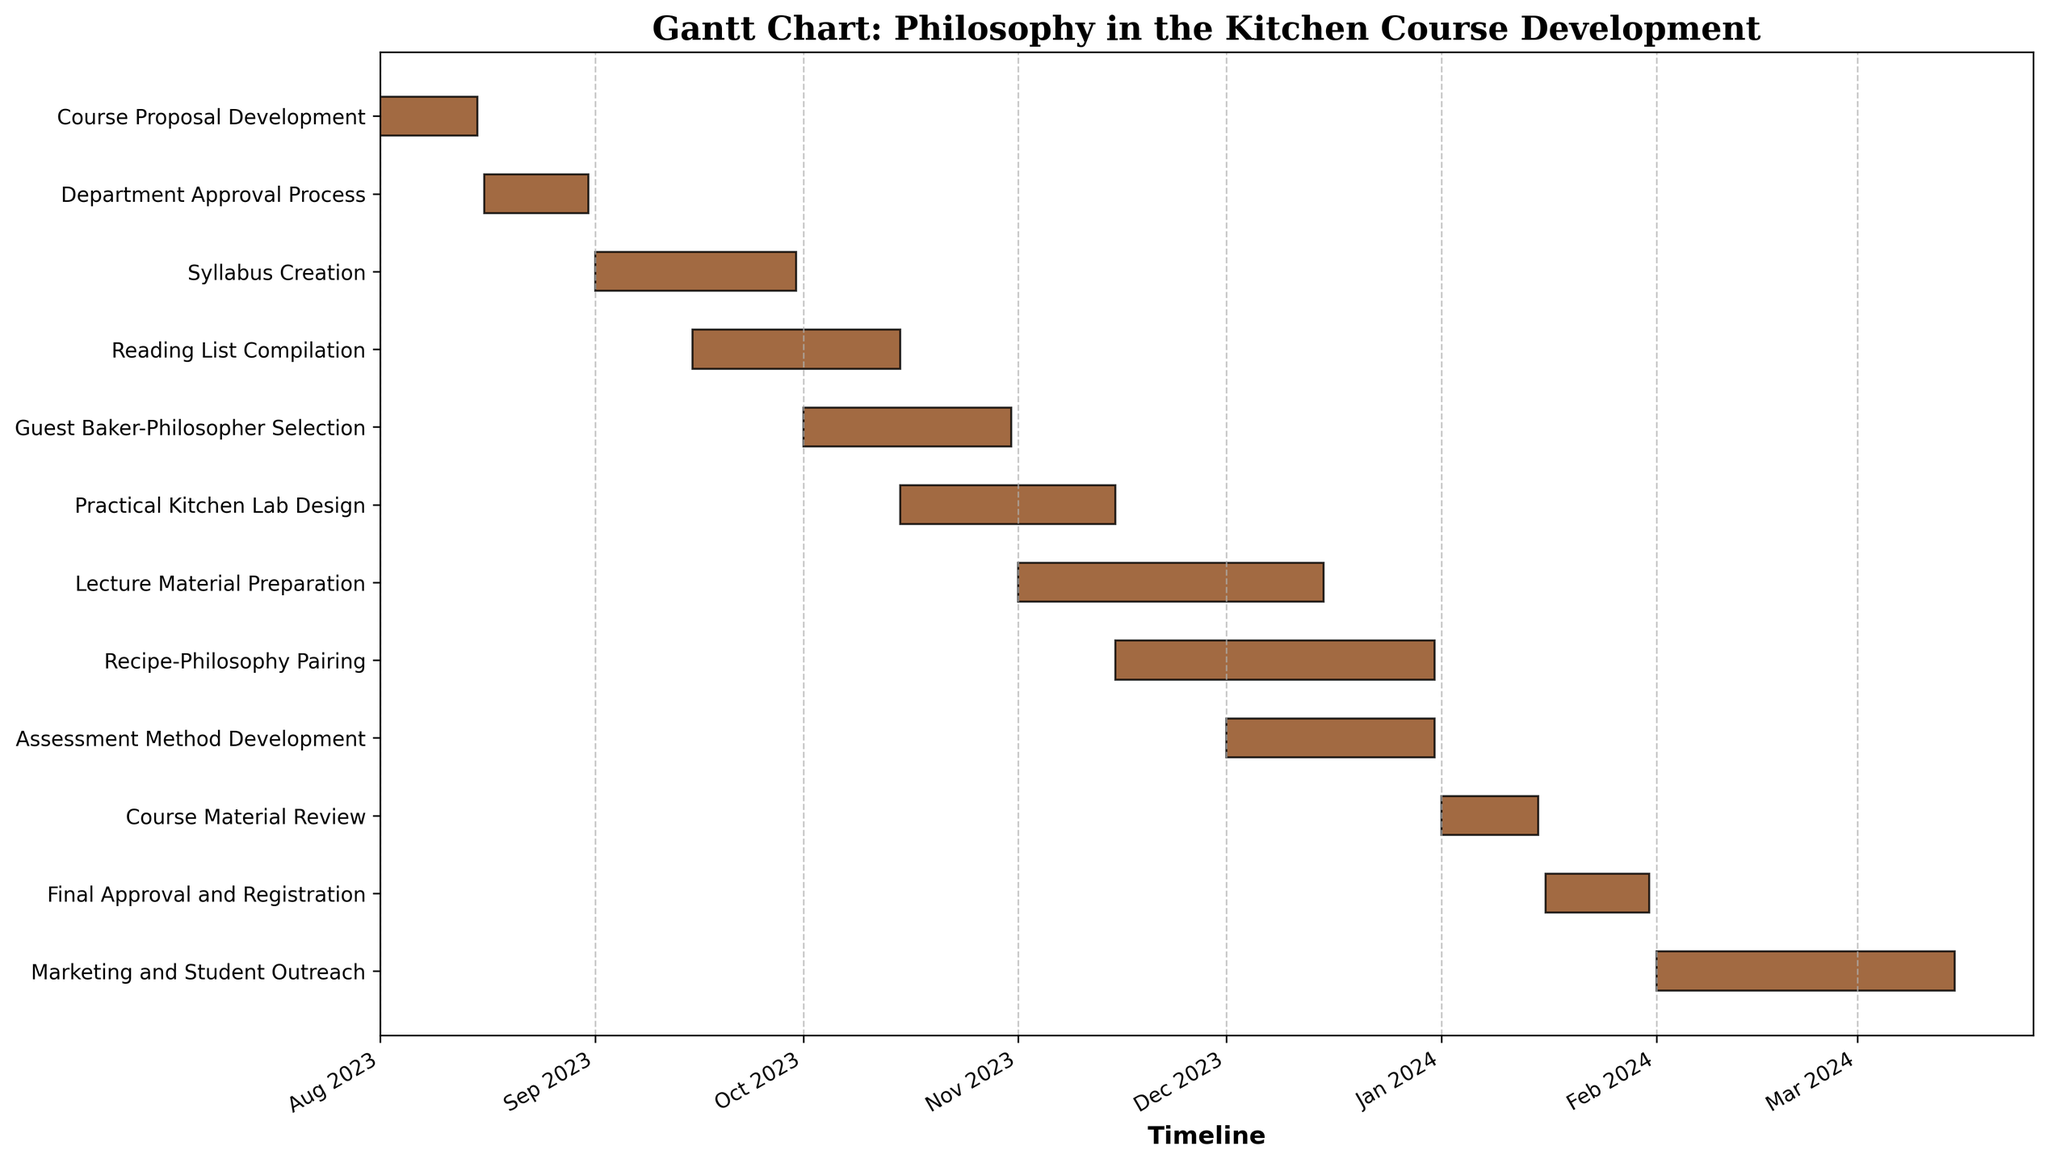What is the title of the Gantt chart? The title is usually located at the top of the Gantt chart and is prominently displayed. It is used to inform the viewer about the main subject of the chart. In this case, it reads "Gantt Chart: Philosophy in the Kitchen Course Development".
Answer: Gantt Chart: Philosophy in the Kitchen Course Development How many tasks are scheduled to start in August 2023? By looking at the start dates of the tasks listed on the left side of the chart, identify which tasks begin in August 2023. "Course Proposal Development" and "Department Approval Process" both start in August 2023.
Answer: 2 What is the duration of "Lecture Material Preparation"? To find the duration, refer to the bar representing "Lecture Material Preparation" on the Gantt chart, which extends from the start date in November 2023 to the end date in December 2023. The duration specified in the data is 45 days.
Answer: 45 Which task has the longest duration, and how long is it? By comparing the lengths of all the bars representing each task, you can see that "Recipe-Philosophy Pairing" stretches the longest. According to the data provided, this task lasts for 47 days.
Answer: Recipe-Philosophy Pairing, 47 days Which tasks overlap with the "Reading List Compilation"? Identify the tasks that have any portion of their bar overlapping with the duration of the “Reading List Compilation” from mid-September to mid-October 2023. The tasks overlapping are "Syllabus Creation" and "Guest Baker-Philosopher Selection".
Answer: Syllabus Creation, Guest Baker-Philosopher Selection When does "Course Material Review" start and end? Refer to the "Course Material Review" bar on the Gantt chart to find its start and end dates. According to the chart, it starts in January 2024 and ends in mid-January 2024.
Answer: January 1, 2024, to January 15, 2024 How many tasks are scheduled to be completed by the end of 2023? Identify tasks whose end dates fall on or before December 31, 2023, using the bar lengths and their endpoints on the timeline. This includes tasks from "Course Proposal Development" to "Assessment Method Development".
Answer: 9 Which tasks begin in October 2023? Cross-reference the start dates of tasks with the timeline on the Gantt chart. "Reading List Compilation" and "Guest Baker-Philosopher Selection" both start in October 2023.
Answer: Guest Baker-Philosopher Selection, Practical Kitchen Lab Design What is the total duration of the entire project from the first to the last task? Calculate the span from the start of "Course Proposal Development" on August 1, 2023, to the end of "Marketing and Student Outreach" on March 15, 2024. This involves adding up the months and days covered.
Answer: 227 days 